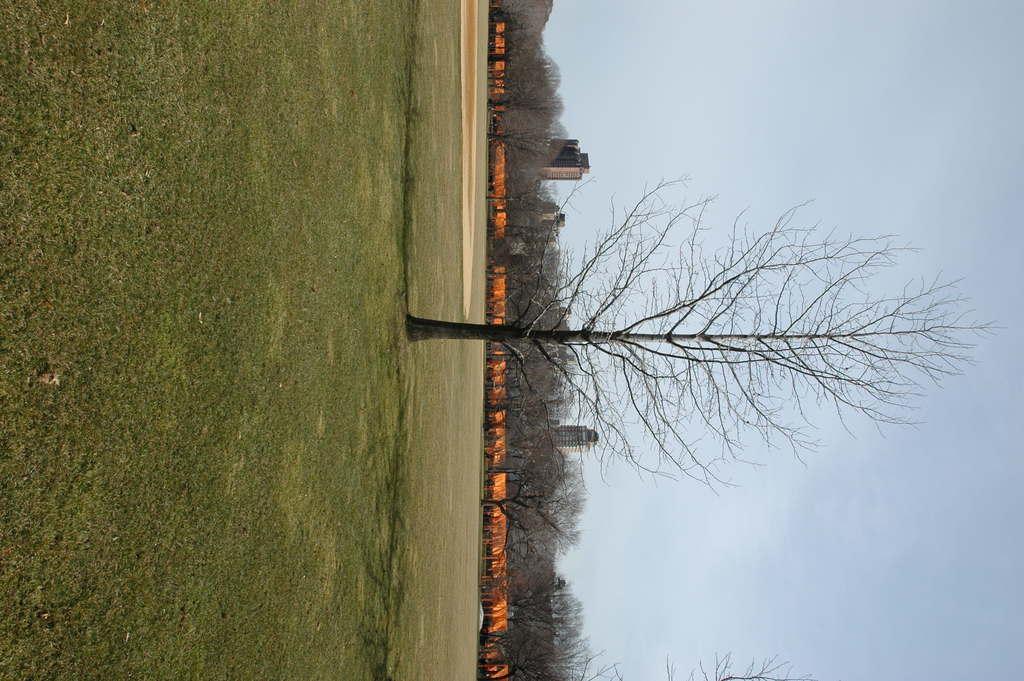Can you describe this image briefly? In the image I can see the ground, some grass on the ground and a tree. In the background I can see few orange colored objects, few trees, few buildings and the sky. 